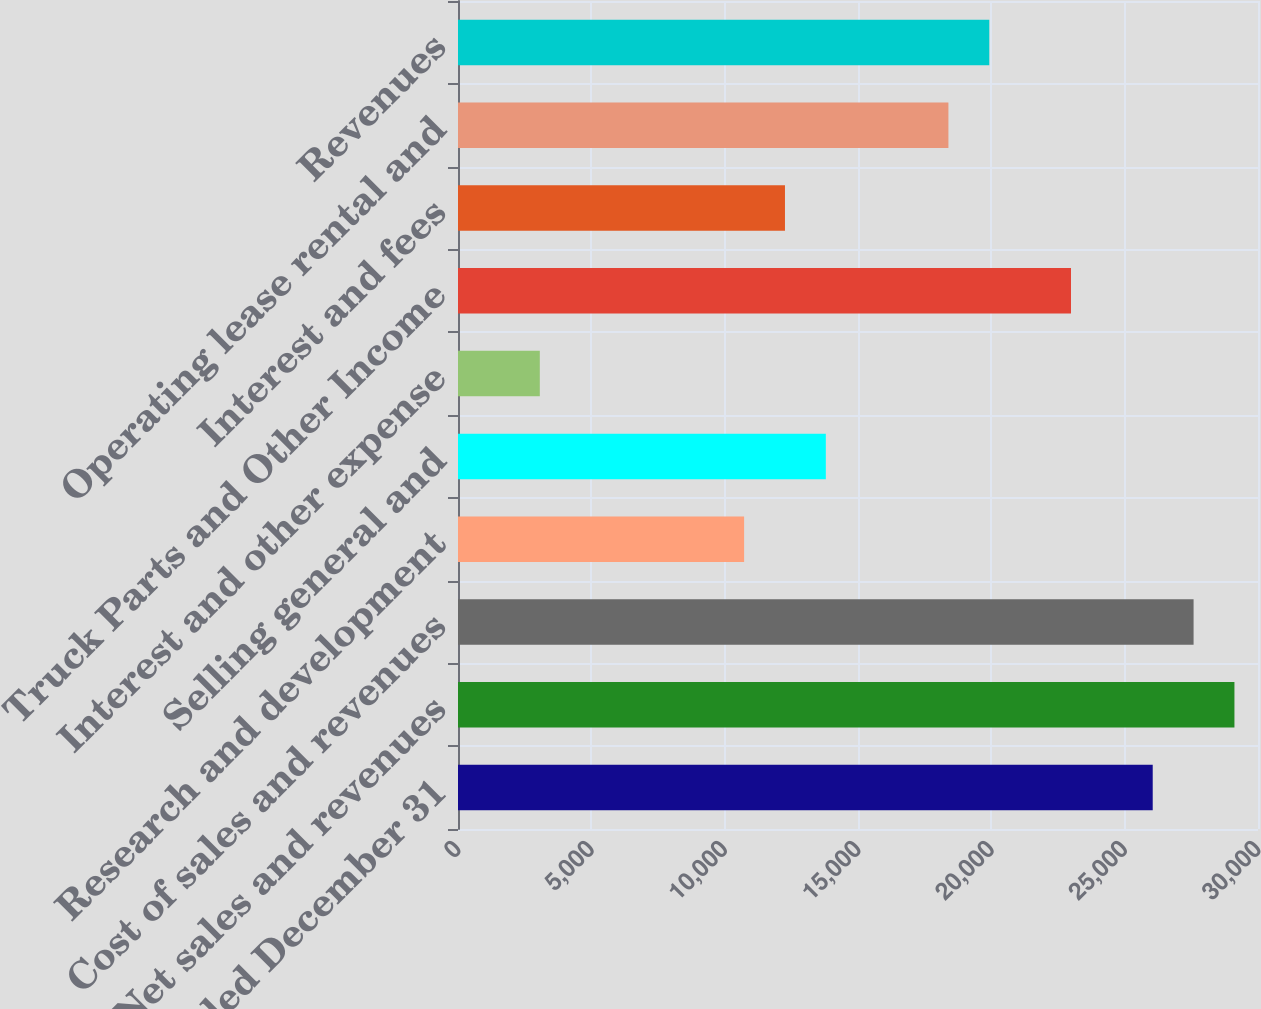Convert chart to OTSL. <chart><loc_0><loc_0><loc_500><loc_500><bar_chart><fcel>Year Ended December 31<fcel>Net sales and revenues<fcel>Cost of sales and revenues<fcel>Research and development<fcel>Selling general and<fcel>Interest and other expense<fcel>Truck Parts and Other Income<fcel>Interest and fees<fcel>Operating lease rental and<fcel>Revenues<nl><fcel>26052<fcel>29116.6<fcel>27584.3<fcel>10729<fcel>13793.6<fcel>3067.46<fcel>22987.4<fcel>12261.3<fcel>18390.5<fcel>19922.8<nl></chart> 